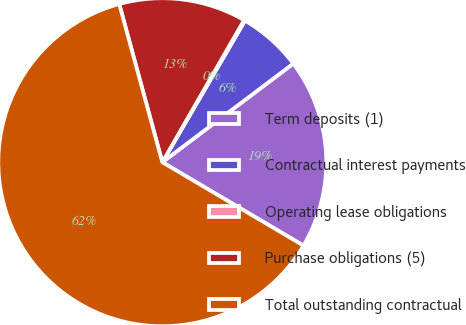Convert chart to OTSL. <chart><loc_0><loc_0><loc_500><loc_500><pie_chart><fcel>Term deposits (1)<fcel>Contractual interest payments<fcel>Operating lease obligations<fcel>Purchase obligations (5)<fcel>Total outstanding contractual<nl><fcel>18.76%<fcel>6.32%<fcel>0.1%<fcel>12.54%<fcel>62.28%<nl></chart> 